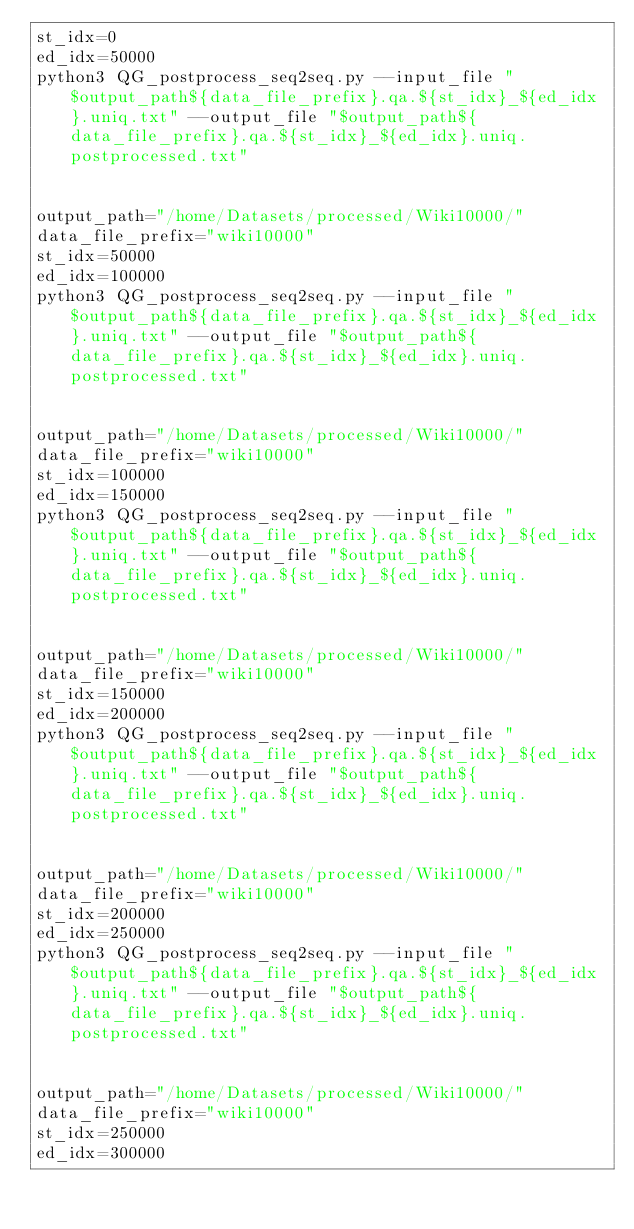<code> <loc_0><loc_0><loc_500><loc_500><_Bash_>st_idx=0
ed_idx=50000
python3 QG_postprocess_seq2seq.py --input_file "$output_path${data_file_prefix}.qa.${st_idx}_${ed_idx}.uniq.txt" --output_file "$output_path${data_file_prefix}.qa.${st_idx}_${ed_idx}.uniq.postprocessed.txt"


output_path="/home/Datasets/processed/Wiki10000/"
data_file_prefix="wiki10000"
st_idx=50000
ed_idx=100000
python3 QG_postprocess_seq2seq.py --input_file "$output_path${data_file_prefix}.qa.${st_idx}_${ed_idx}.uniq.txt" --output_file "$output_path${data_file_prefix}.qa.${st_idx}_${ed_idx}.uniq.postprocessed.txt" 


output_path="/home/Datasets/processed/Wiki10000/"
data_file_prefix="wiki10000"
st_idx=100000
ed_idx=150000
python3 QG_postprocess_seq2seq.py --input_file "$output_path${data_file_prefix}.qa.${st_idx}_${ed_idx}.uniq.txt" --output_file "$output_path${data_file_prefix}.qa.${st_idx}_${ed_idx}.uniq.postprocessed.txt"


output_path="/home/Datasets/processed/Wiki10000/"
data_file_prefix="wiki10000"
st_idx=150000
ed_idx=200000
python3 QG_postprocess_seq2seq.py --input_file "$output_path${data_file_prefix}.qa.${st_idx}_${ed_idx}.uniq.txt" --output_file "$output_path${data_file_prefix}.qa.${st_idx}_${ed_idx}.uniq.postprocessed.txt" 


output_path="/home/Datasets/processed/Wiki10000/"
data_file_prefix="wiki10000"
st_idx=200000
ed_idx=250000
python3 QG_postprocess_seq2seq.py --input_file "$output_path${data_file_prefix}.qa.${st_idx}_${ed_idx}.uniq.txt" --output_file "$output_path${data_file_prefix}.qa.${st_idx}_${ed_idx}.uniq.postprocessed.txt" 


output_path="/home/Datasets/processed/Wiki10000/"
data_file_prefix="wiki10000"
st_idx=250000
ed_idx=300000</code> 